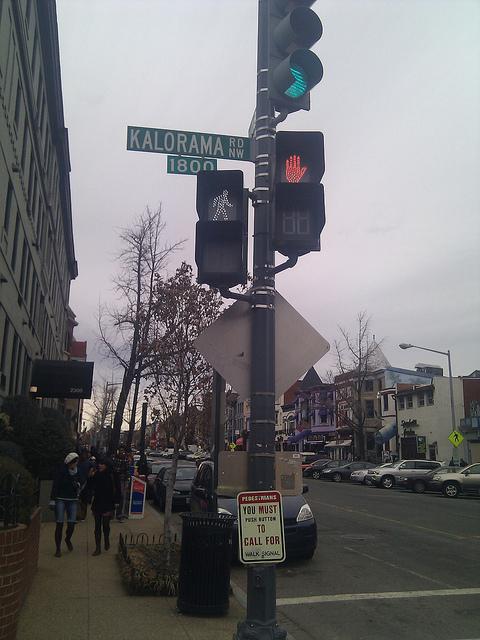Is it warm or cold outside?
Quick response, please. Cold. What color is the light?
Answer briefly. Green. What street is it?
Quick response, please. Kalorama. Is this a traffic light often seen in the US?
Answer briefly. Yes. What does the P above the machine mean?
Give a very brief answer. Parking. Is this an urban or rural location?
Keep it brief. Urban. What color light is illuminated on the signal?
Short answer required. Green. Is the bottom sign secure?
Be succinct. Yes. What is the name of the street on the sign?
Quick response, please. Kalorama. 